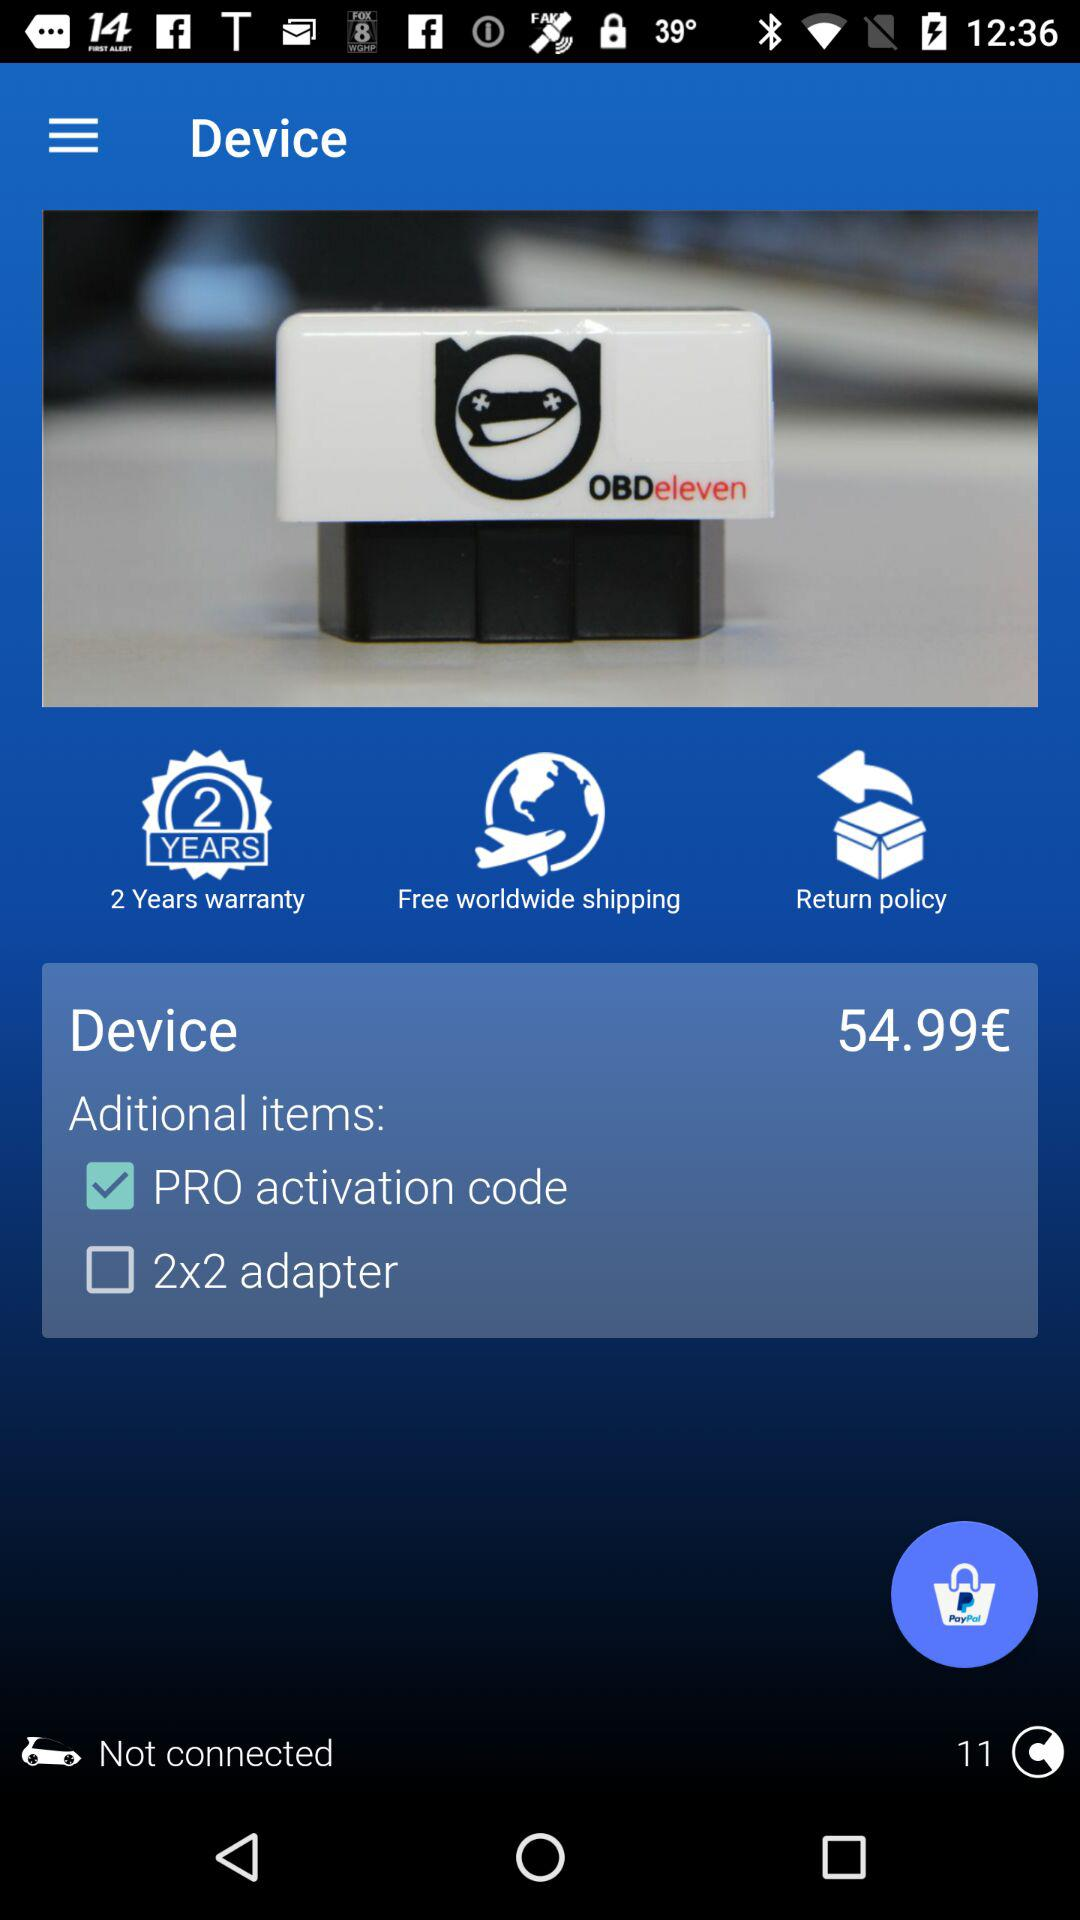What are the additional items available with the device? The additional items available with the device are "PRO activation code" and "2x2 adapter". 